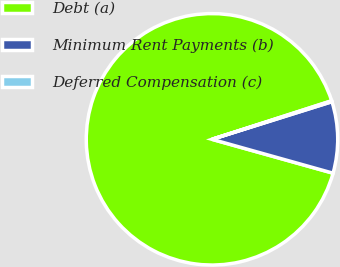Convert chart. <chart><loc_0><loc_0><loc_500><loc_500><pie_chart><fcel>Debt (a)<fcel>Minimum Rent Payments (b)<fcel>Deferred Compensation (c)<nl><fcel>90.7%<fcel>9.18%<fcel>0.12%<nl></chart> 